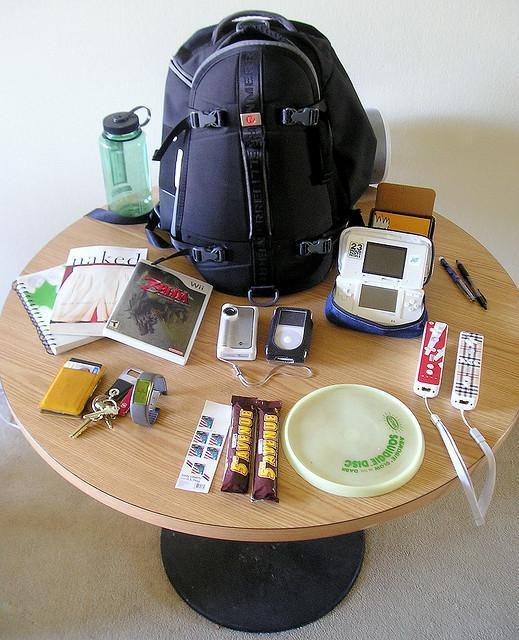How many books are visible?
Give a very brief answer. 2. How many of the buses visible on the street are two story?
Give a very brief answer. 0. 